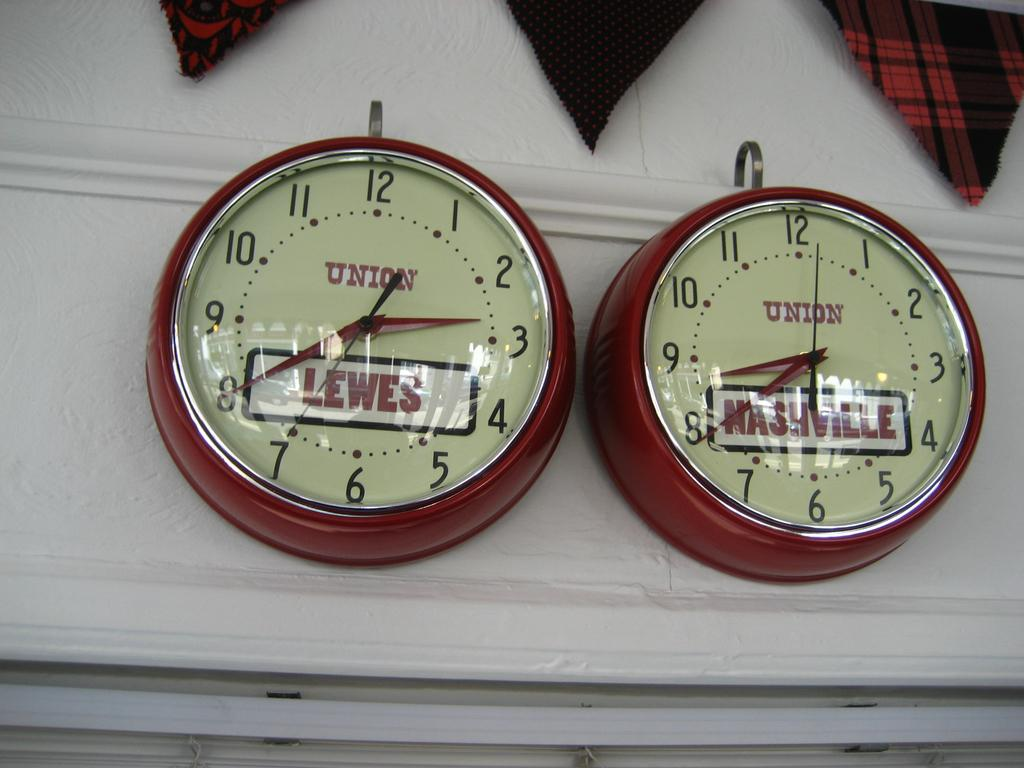<image>
Offer a succinct explanation of the picture presented. The Union clocks show, Lewes is 6 hours behind Nashville's time. 